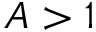Convert formula to latex. <formula><loc_0><loc_0><loc_500><loc_500>A > 1</formula> 